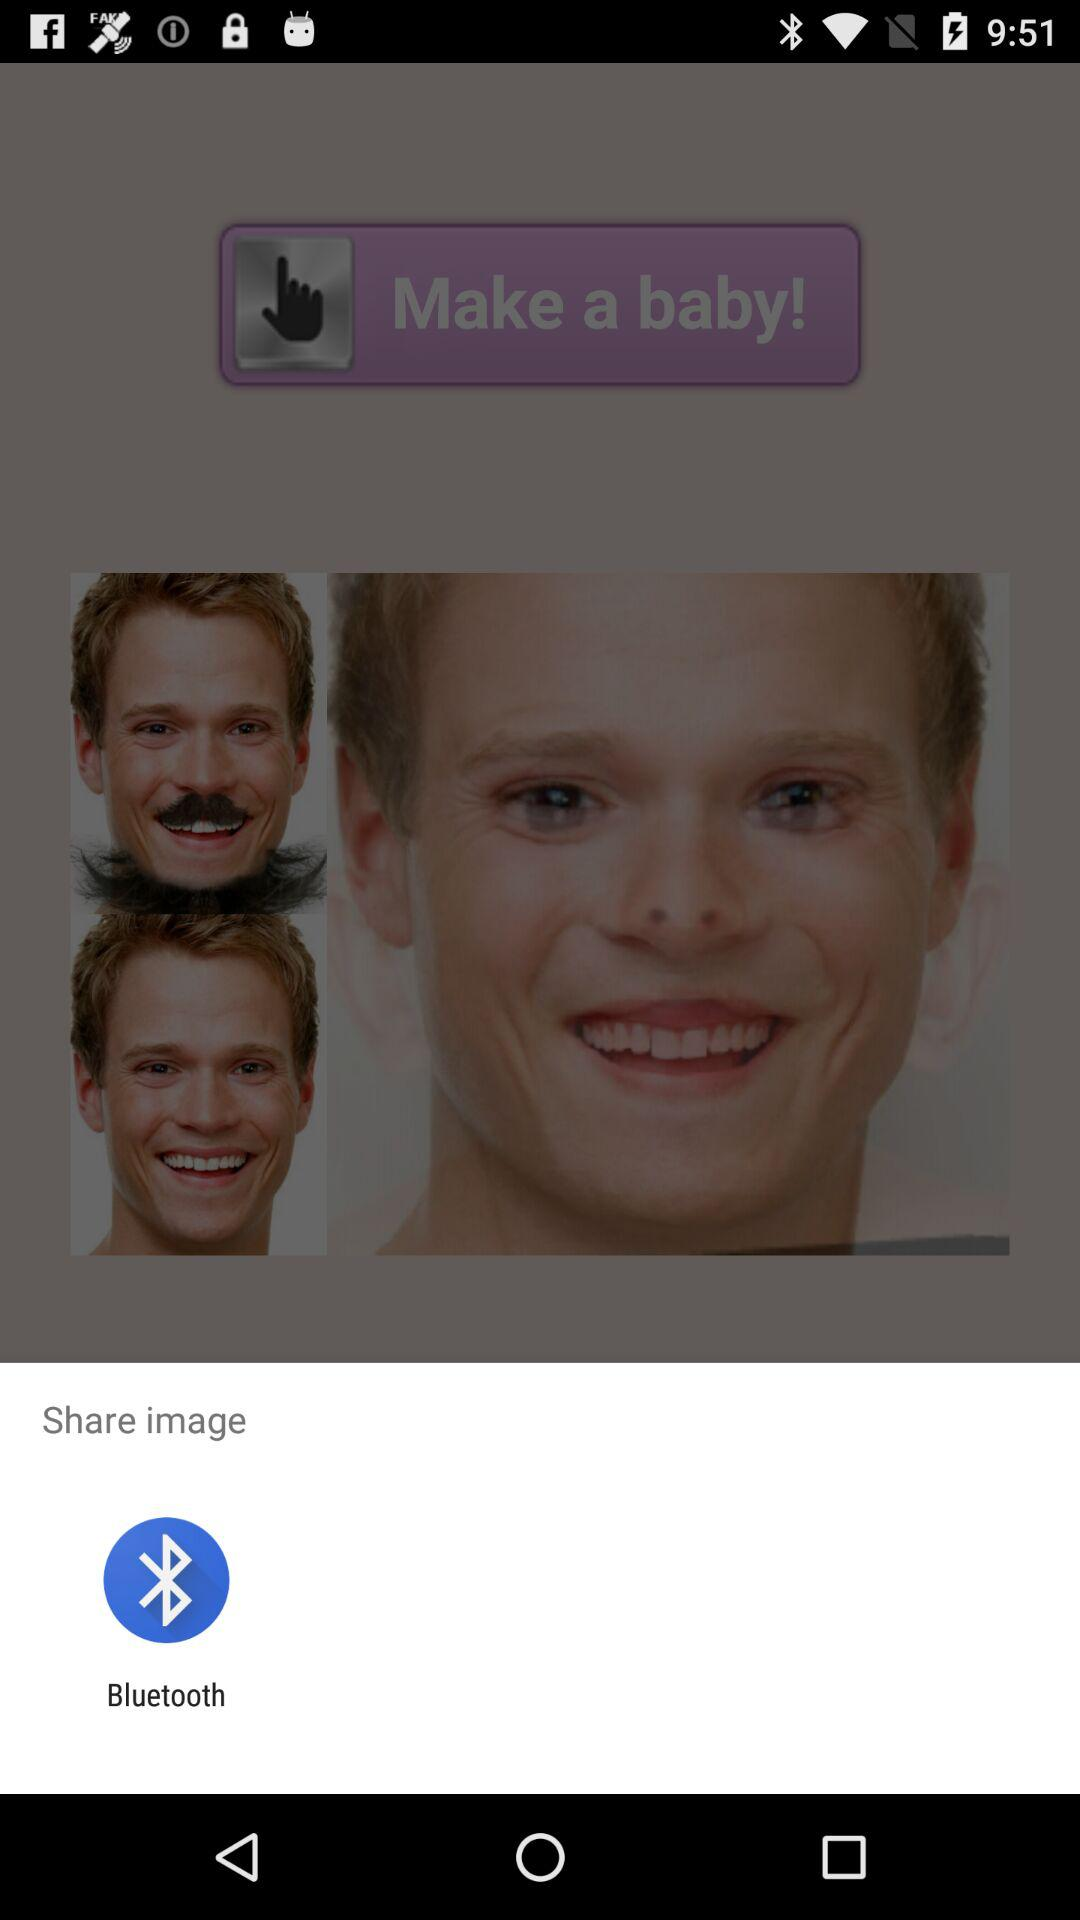Where can I share this image? You can share this image with "Bluetooth". 